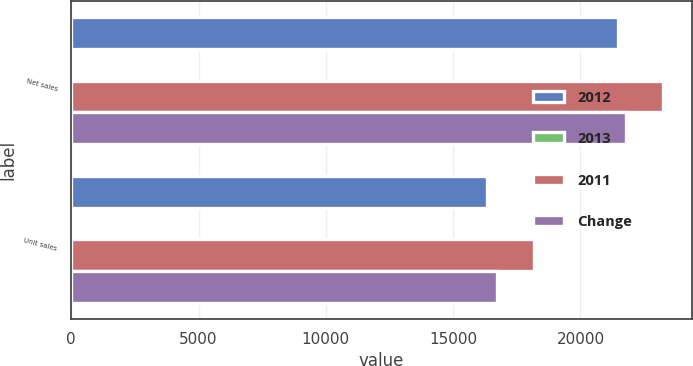<chart> <loc_0><loc_0><loc_500><loc_500><stacked_bar_chart><ecel><fcel>Net sales<fcel>Unit sales<nl><fcel>2012<fcel>21483<fcel>16341<nl><fcel>2013<fcel>7<fcel>10<nl><fcel>2011<fcel>23221<fcel>18158<nl><fcel>Change<fcel>21783<fcel>16735<nl></chart> 